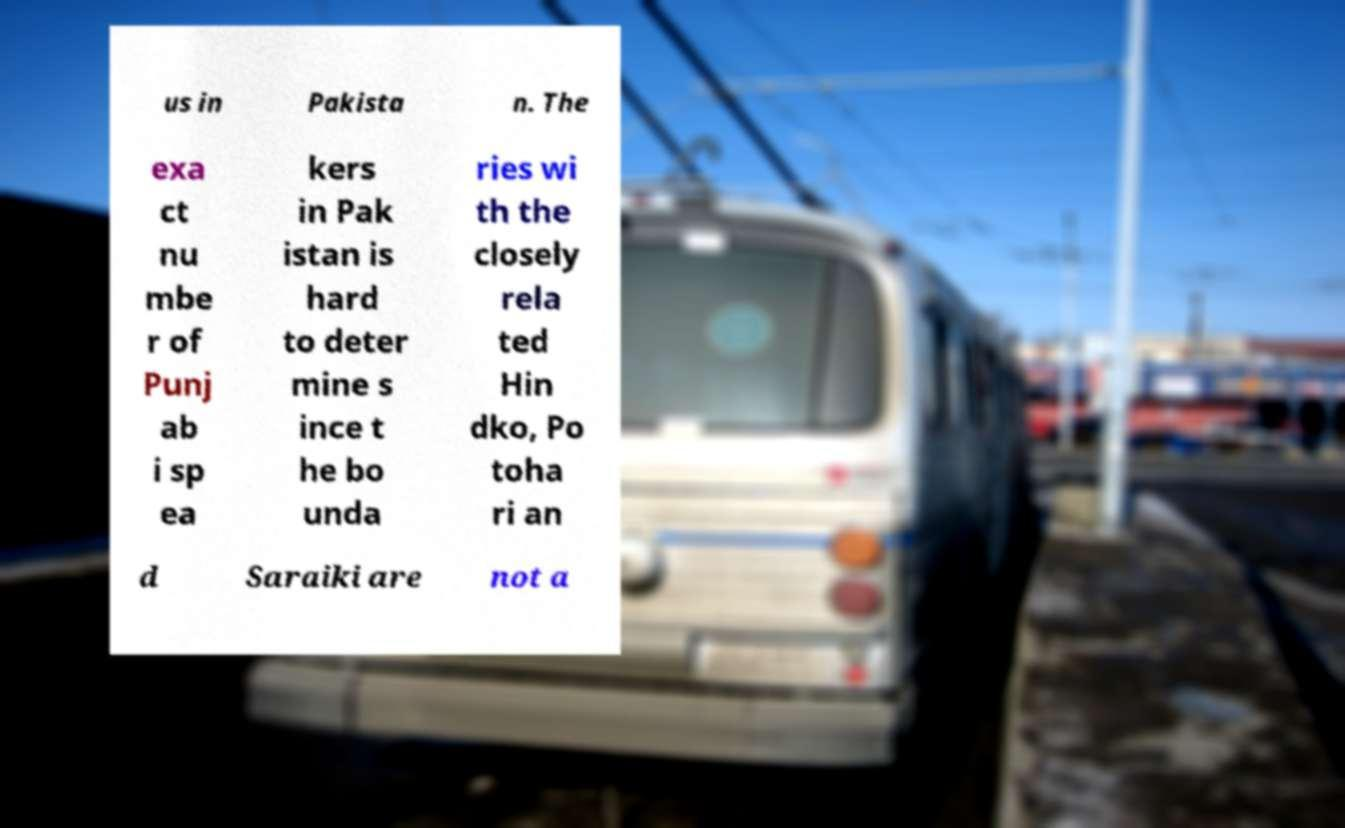For documentation purposes, I need the text within this image transcribed. Could you provide that? us in Pakista n. The exa ct nu mbe r of Punj ab i sp ea kers in Pak istan is hard to deter mine s ince t he bo unda ries wi th the closely rela ted Hin dko, Po toha ri an d Saraiki are not a 